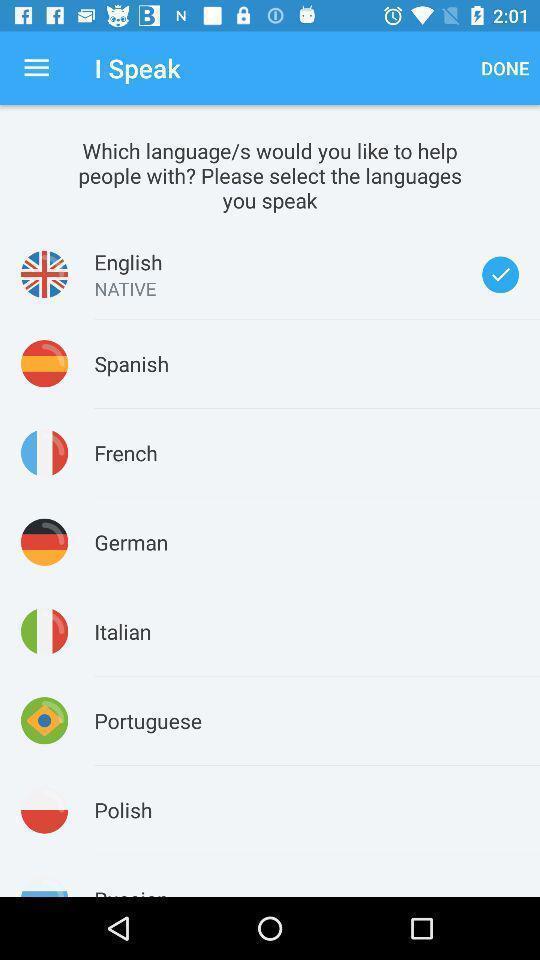Tell me about the visual elements in this screen capture. Page displaying the list of different languages. 